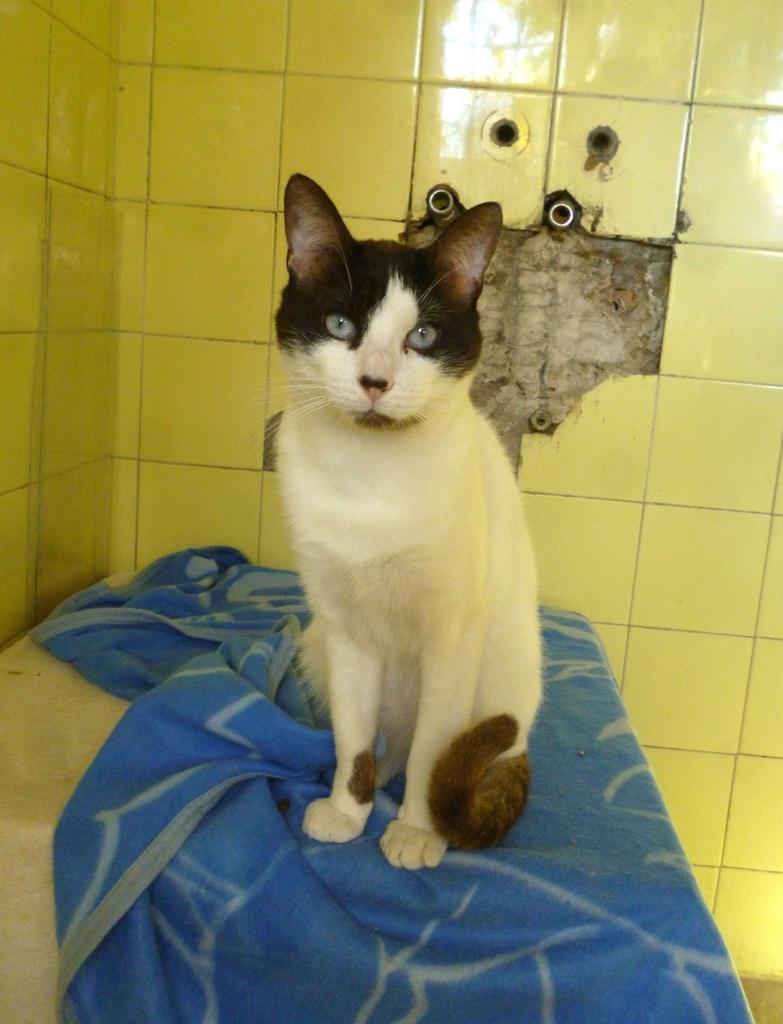Can you describe this image briefly? In this image we can see a cat sitting on a blanket. There is a tile wall in the image. There is some reflection on the tile wall. There are few pipes in a wall. 